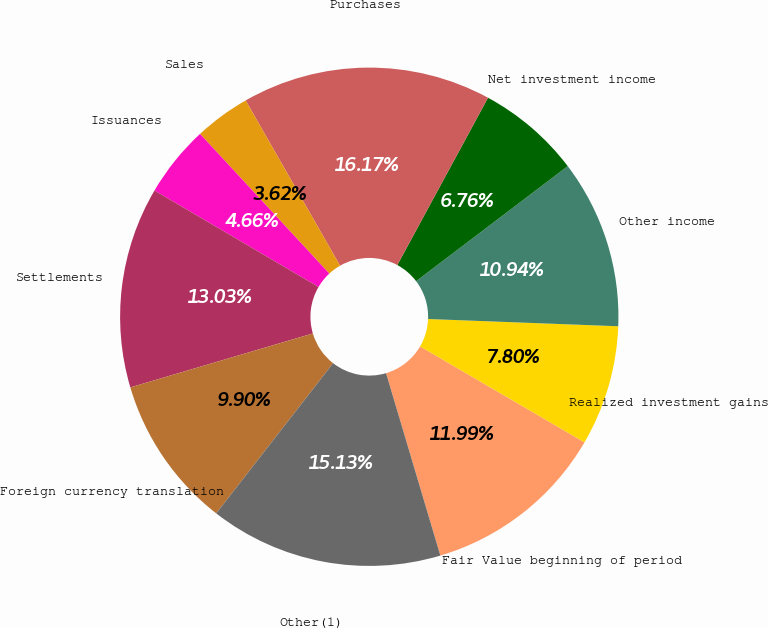Convert chart. <chart><loc_0><loc_0><loc_500><loc_500><pie_chart><fcel>Fair Value beginning of period<fcel>Realized investment gains<fcel>Other income<fcel>Net investment income<fcel>Purchases<fcel>Sales<fcel>Issuances<fcel>Settlements<fcel>Foreign currency translation<fcel>Other(1)<nl><fcel>11.99%<fcel>7.8%<fcel>10.94%<fcel>6.76%<fcel>16.17%<fcel>3.62%<fcel>4.66%<fcel>13.03%<fcel>9.9%<fcel>15.13%<nl></chart> 